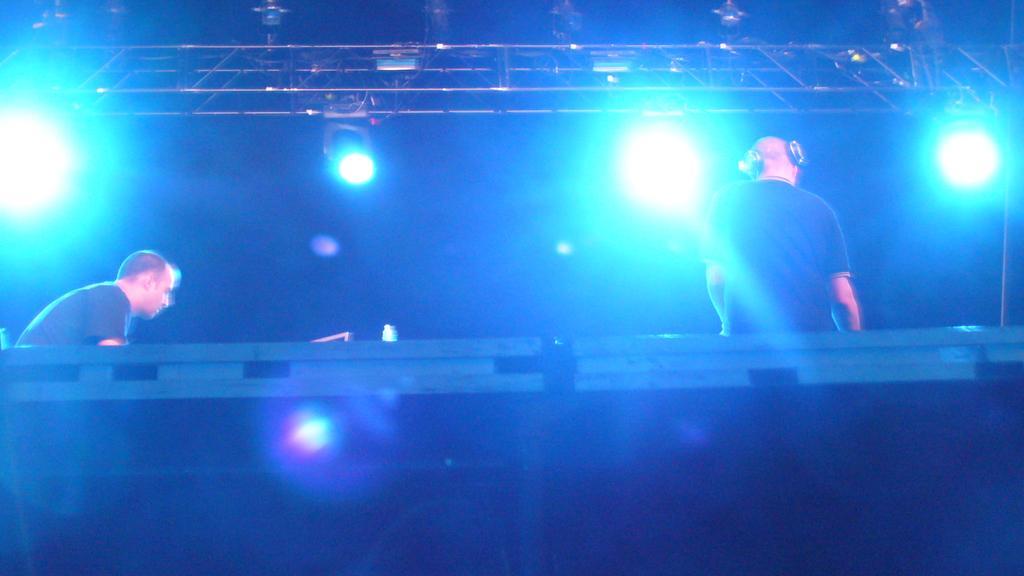Could you give a brief overview of what you see in this image? In this image I can see two persons wearing black colored dress. I can see few metal rods and few lights. I can see the dark background. 